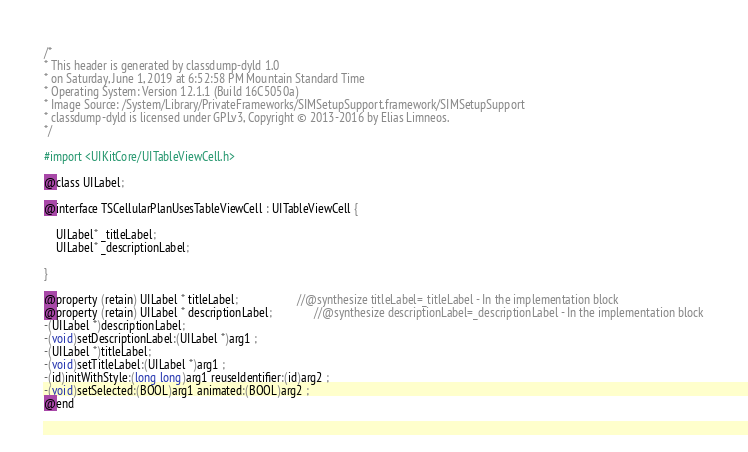<code> <loc_0><loc_0><loc_500><loc_500><_C_>/*
* This header is generated by classdump-dyld 1.0
* on Saturday, June 1, 2019 at 6:52:58 PM Mountain Standard Time
* Operating System: Version 12.1.1 (Build 16C5050a)
* Image Source: /System/Library/PrivateFrameworks/SIMSetupSupport.framework/SIMSetupSupport
* classdump-dyld is licensed under GPLv3, Copyright © 2013-2016 by Elias Limneos.
*/

#import <UIKitCore/UITableViewCell.h>

@class UILabel;

@interface TSCellularPlanUsesTableViewCell : UITableViewCell {

	UILabel* _titleLabel;
	UILabel* _descriptionLabel;

}

@property (retain) UILabel * titleLabel;                    //@synthesize titleLabel=_titleLabel - In the implementation block
@property (retain) UILabel * descriptionLabel;              //@synthesize descriptionLabel=_descriptionLabel - In the implementation block
-(UILabel *)descriptionLabel;
-(void)setDescriptionLabel:(UILabel *)arg1 ;
-(UILabel *)titleLabel;
-(void)setTitleLabel:(UILabel *)arg1 ;
-(id)initWithStyle:(long long)arg1 reuseIdentifier:(id)arg2 ;
-(void)setSelected:(BOOL)arg1 animated:(BOOL)arg2 ;
@end

</code> 